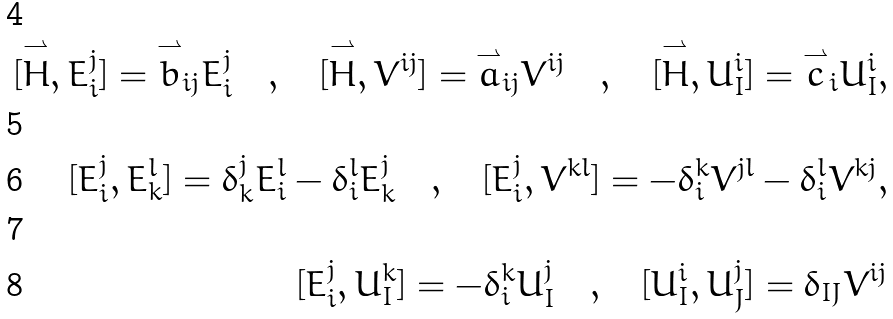<formula> <loc_0><loc_0><loc_500><loc_500>[ \overset { \rightharpoonup } { H } , E _ { i } ^ { j } ] = \overset { \rightharpoonup } { b } _ { i j } E _ { i } ^ { j } \quad , \quad [ \overset { \rightharpoonup } { H } , V ^ { i j } ] = \overset { \rightharpoonup } { a } _ { i j } V ^ { i j } \quad , \quad [ \overset { \rightharpoonup } { H } , U _ { I } ^ { i } ] = \overset { \rightharpoonup } { c } _ { i } U _ { I } ^ { i } , \\ \\ [ E _ { i } ^ { j } , E _ { k } ^ { l } ] = \delta _ { k } ^ { j } E _ { i } ^ { l } - \delta _ { i } ^ { l } E _ { k } ^ { j } \quad , \quad [ E _ { i } ^ { j } , V ^ { k l } ] = - \delta _ { i } ^ { k } V ^ { j l } - \delta _ { i } ^ { l } V ^ { k j } , \\ \\ [ E _ { i } ^ { j } , U _ { I } ^ { k } ] = - \delta _ { i } ^ { k } U _ { I } ^ { j } \quad , \quad [ U _ { I } ^ { i } , U _ { J } ^ { j } ] = \delta _ { I J } V ^ { i j }</formula> 